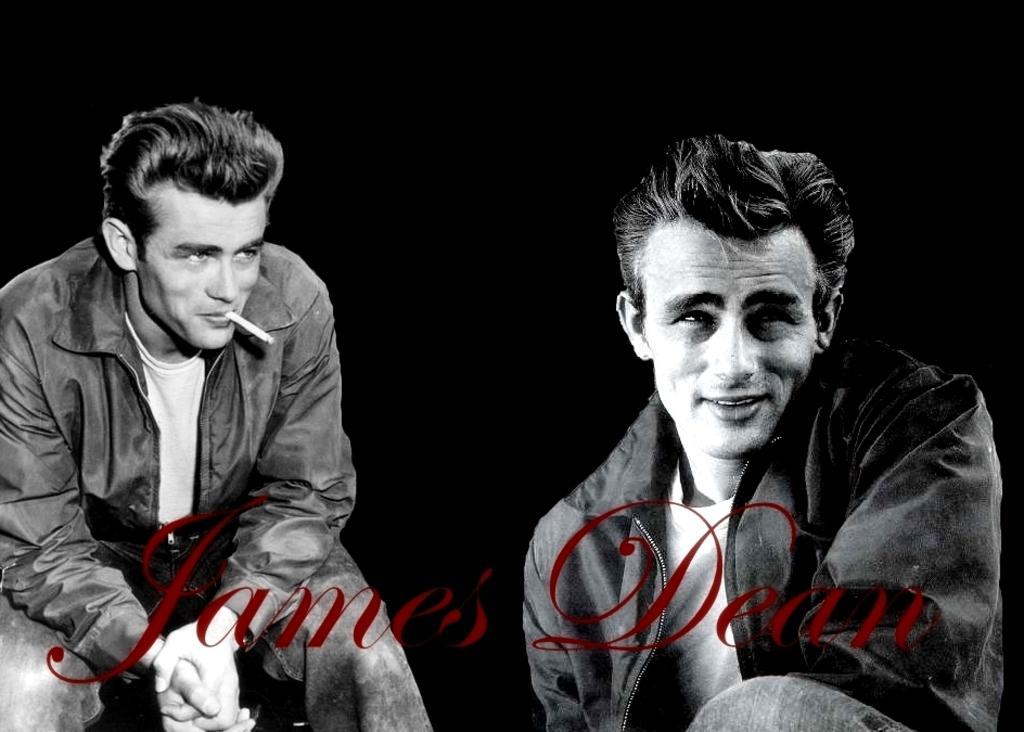Describe this image in one or two sentences. On the right side of the image there is a person wearing a smile on his face. On the left side of the image there is a person sitting and he is holding the cigarette in his mouth. There is some text at the bottom of the image. 